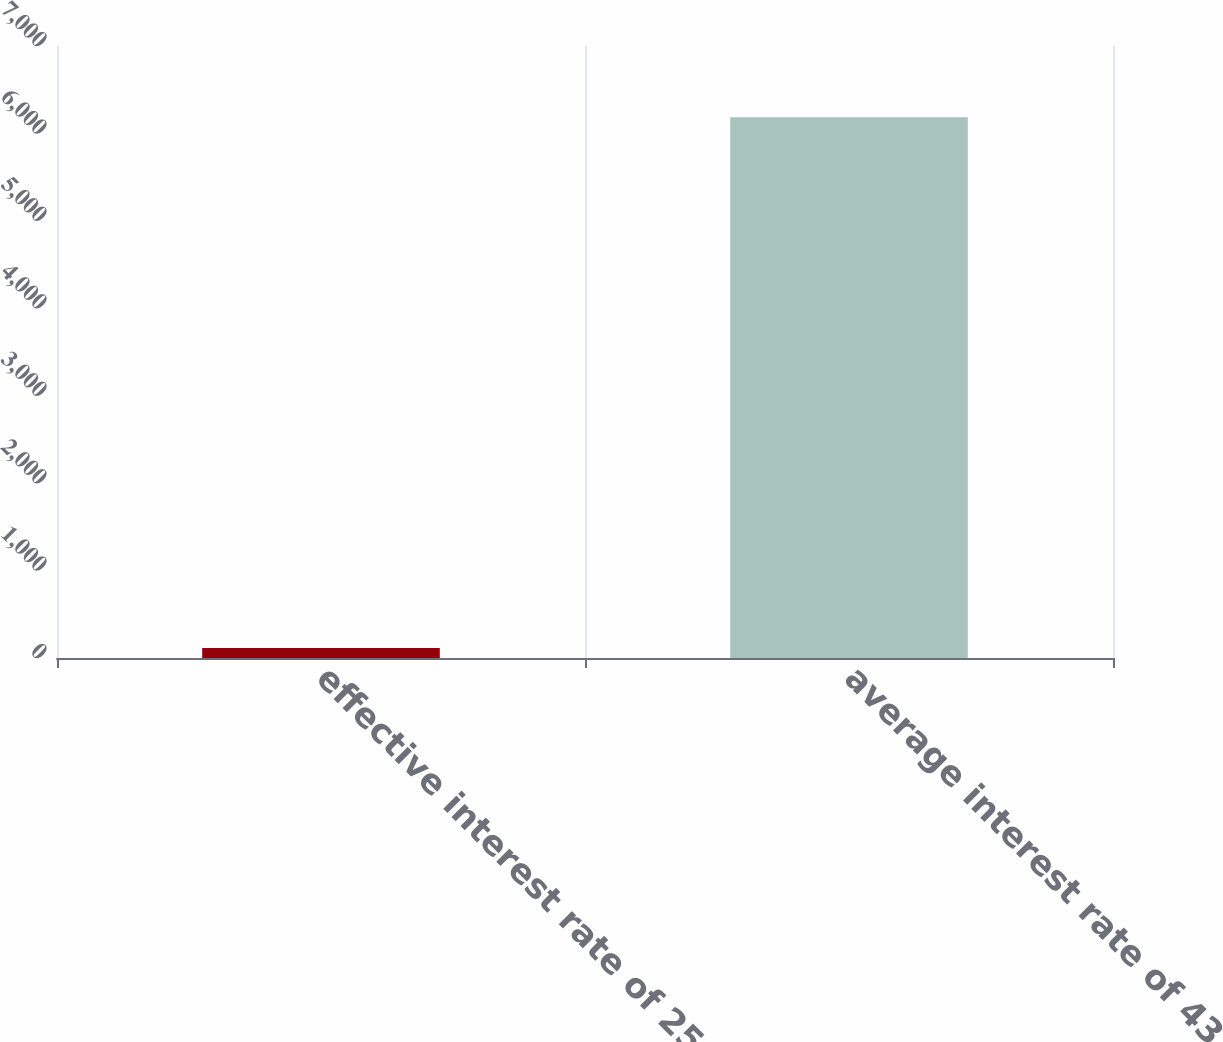Convert chart to OTSL. <chart><loc_0><loc_0><loc_500><loc_500><bar_chart><fcel>effective interest rate of 25<fcel>average interest rate of 43 as<nl><fcel>113<fcel>6184<nl></chart> 